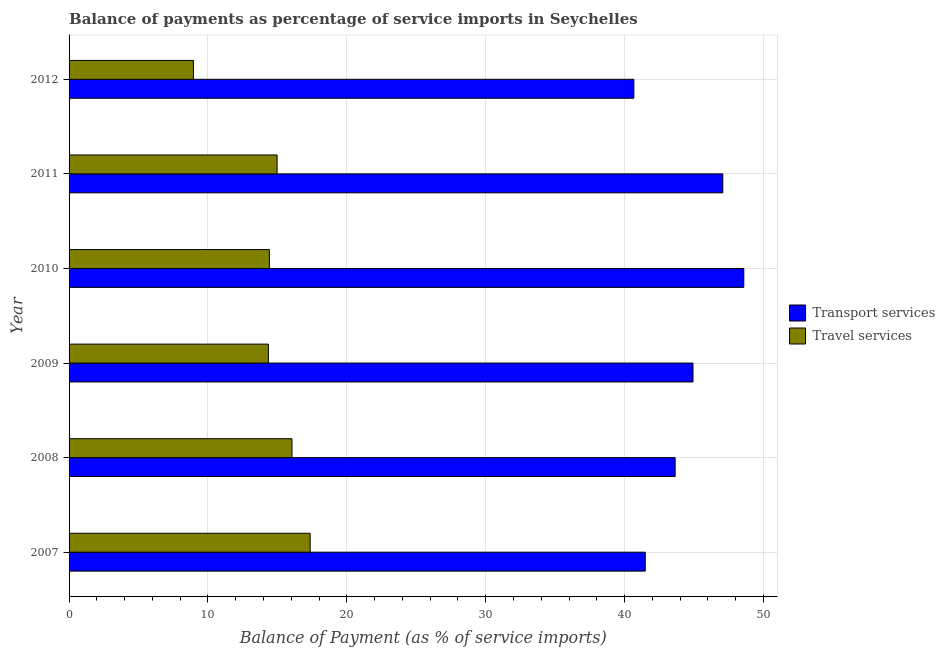How many groups of bars are there?
Your answer should be compact. 6. Are the number of bars on each tick of the Y-axis equal?
Provide a short and direct response. Yes. How many bars are there on the 1st tick from the bottom?
Give a very brief answer. 2. What is the balance of payments of transport services in 2010?
Make the answer very short. 48.59. Across all years, what is the maximum balance of payments of transport services?
Provide a short and direct response. 48.59. Across all years, what is the minimum balance of payments of transport services?
Give a very brief answer. 40.67. In which year was the balance of payments of travel services minimum?
Offer a terse response. 2012. What is the total balance of payments of transport services in the graph?
Your answer should be compact. 266.4. What is the difference between the balance of payments of transport services in 2007 and that in 2010?
Your answer should be compact. -7.1. What is the difference between the balance of payments of transport services in 2008 and the balance of payments of travel services in 2007?
Ensure brevity in your answer.  26.28. What is the average balance of payments of transport services per year?
Give a very brief answer. 44.4. In the year 2008, what is the difference between the balance of payments of transport services and balance of payments of travel services?
Keep it short and to the point. 27.59. Is the balance of payments of travel services in 2007 less than that in 2009?
Your answer should be very brief. No. Is the difference between the balance of payments of travel services in 2010 and 2012 greater than the difference between the balance of payments of transport services in 2010 and 2012?
Your answer should be compact. No. What is the difference between the highest and the second highest balance of payments of transport services?
Ensure brevity in your answer.  1.51. What is the difference between the highest and the lowest balance of payments of travel services?
Provide a succinct answer. 8.41. In how many years, is the balance of payments of transport services greater than the average balance of payments of transport services taken over all years?
Your answer should be compact. 3. Is the sum of the balance of payments of transport services in 2009 and 2010 greater than the maximum balance of payments of travel services across all years?
Give a very brief answer. Yes. What does the 1st bar from the top in 2012 represents?
Your answer should be very brief. Travel services. What does the 2nd bar from the bottom in 2012 represents?
Make the answer very short. Travel services. Are all the bars in the graph horizontal?
Your answer should be very brief. Yes. What is the difference between two consecutive major ticks on the X-axis?
Your answer should be very brief. 10. Does the graph contain any zero values?
Provide a succinct answer. No. Does the graph contain grids?
Provide a succinct answer. Yes. Where does the legend appear in the graph?
Give a very brief answer. Center right. What is the title of the graph?
Your response must be concise. Balance of payments as percentage of service imports in Seychelles. What is the label or title of the X-axis?
Provide a succinct answer. Balance of Payment (as % of service imports). What is the Balance of Payment (as % of service imports) of Transport services in 2007?
Offer a very short reply. 41.49. What is the Balance of Payment (as % of service imports) in Travel services in 2007?
Provide a short and direct response. 17.36. What is the Balance of Payment (as % of service imports) in Transport services in 2008?
Ensure brevity in your answer.  43.64. What is the Balance of Payment (as % of service imports) in Travel services in 2008?
Your response must be concise. 16.05. What is the Balance of Payment (as % of service imports) in Transport services in 2009?
Offer a very short reply. 44.93. What is the Balance of Payment (as % of service imports) in Travel services in 2009?
Provide a short and direct response. 14.35. What is the Balance of Payment (as % of service imports) in Transport services in 2010?
Provide a short and direct response. 48.59. What is the Balance of Payment (as % of service imports) in Travel services in 2010?
Make the answer very short. 14.43. What is the Balance of Payment (as % of service imports) of Transport services in 2011?
Your response must be concise. 47.08. What is the Balance of Payment (as % of service imports) of Travel services in 2011?
Offer a terse response. 14.98. What is the Balance of Payment (as % of service imports) of Transport services in 2012?
Your answer should be compact. 40.67. What is the Balance of Payment (as % of service imports) of Travel services in 2012?
Your answer should be compact. 8.96. Across all years, what is the maximum Balance of Payment (as % of service imports) in Transport services?
Your answer should be very brief. 48.59. Across all years, what is the maximum Balance of Payment (as % of service imports) in Travel services?
Keep it short and to the point. 17.36. Across all years, what is the minimum Balance of Payment (as % of service imports) in Transport services?
Keep it short and to the point. 40.67. Across all years, what is the minimum Balance of Payment (as % of service imports) in Travel services?
Provide a succinct answer. 8.96. What is the total Balance of Payment (as % of service imports) of Transport services in the graph?
Give a very brief answer. 266.4. What is the total Balance of Payment (as % of service imports) in Travel services in the graph?
Ensure brevity in your answer.  86.13. What is the difference between the Balance of Payment (as % of service imports) in Transport services in 2007 and that in 2008?
Provide a succinct answer. -2.15. What is the difference between the Balance of Payment (as % of service imports) in Travel services in 2007 and that in 2008?
Give a very brief answer. 1.31. What is the difference between the Balance of Payment (as % of service imports) in Transport services in 2007 and that in 2009?
Offer a terse response. -3.44. What is the difference between the Balance of Payment (as % of service imports) in Travel services in 2007 and that in 2009?
Offer a very short reply. 3.01. What is the difference between the Balance of Payment (as % of service imports) of Transport services in 2007 and that in 2010?
Ensure brevity in your answer.  -7.1. What is the difference between the Balance of Payment (as % of service imports) in Travel services in 2007 and that in 2010?
Your answer should be compact. 2.94. What is the difference between the Balance of Payment (as % of service imports) of Transport services in 2007 and that in 2011?
Provide a short and direct response. -5.58. What is the difference between the Balance of Payment (as % of service imports) of Travel services in 2007 and that in 2011?
Make the answer very short. 2.38. What is the difference between the Balance of Payment (as % of service imports) of Transport services in 2007 and that in 2012?
Your answer should be compact. 0.82. What is the difference between the Balance of Payment (as % of service imports) in Travel services in 2007 and that in 2012?
Offer a terse response. 8.41. What is the difference between the Balance of Payment (as % of service imports) of Transport services in 2008 and that in 2009?
Provide a short and direct response. -1.28. What is the difference between the Balance of Payment (as % of service imports) of Travel services in 2008 and that in 2009?
Your answer should be compact. 1.7. What is the difference between the Balance of Payment (as % of service imports) of Transport services in 2008 and that in 2010?
Make the answer very short. -4.94. What is the difference between the Balance of Payment (as % of service imports) of Travel services in 2008 and that in 2010?
Ensure brevity in your answer.  1.63. What is the difference between the Balance of Payment (as % of service imports) in Transport services in 2008 and that in 2011?
Make the answer very short. -3.43. What is the difference between the Balance of Payment (as % of service imports) in Travel services in 2008 and that in 2011?
Provide a short and direct response. 1.07. What is the difference between the Balance of Payment (as % of service imports) in Transport services in 2008 and that in 2012?
Keep it short and to the point. 2.97. What is the difference between the Balance of Payment (as % of service imports) in Travel services in 2008 and that in 2012?
Offer a terse response. 7.1. What is the difference between the Balance of Payment (as % of service imports) in Transport services in 2009 and that in 2010?
Ensure brevity in your answer.  -3.66. What is the difference between the Balance of Payment (as % of service imports) of Travel services in 2009 and that in 2010?
Give a very brief answer. -0.07. What is the difference between the Balance of Payment (as % of service imports) of Transport services in 2009 and that in 2011?
Provide a short and direct response. -2.15. What is the difference between the Balance of Payment (as % of service imports) in Travel services in 2009 and that in 2011?
Keep it short and to the point. -0.63. What is the difference between the Balance of Payment (as % of service imports) in Transport services in 2009 and that in 2012?
Give a very brief answer. 4.26. What is the difference between the Balance of Payment (as % of service imports) in Travel services in 2009 and that in 2012?
Give a very brief answer. 5.4. What is the difference between the Balance of Payment (as % of service imports) in Transport services in 2010 and that in 2011?
Your response must be concise. 1.51. What is the difference between the Balance of Payment (as % of service imports) in Travel services in 2010 and that in 2011?
Keep it short and to the point. -0.55. What is the difference between the Balance of Payment (as % of service imports) of Transport services in 2010 and that in 2012?
Give a very brief answer. 7.92. What is the difference between the Balance of Payment (as % of service imports) in Travel services in 2010 and that in 2012?
Provide a short and direct response. 5.47. What is the difference between the Balance of Payment (as % of service imports) in Transport services in 2011 and that in 2012?
Offer a terse response. 6.41. What is the difference between the Balance of Payment (as % of service imports) of Travel services in 2011 and that in 2012?
Keep it short and to the point. 6.03. What is the difference between the Balance of Payment (as % of service imports) of Transport services in 2007 and the Balance of Payment (as % of service imports) of Travel services in 2008?
Provide a succinct answer. 25.44. What is the difference between the Balance of Payment (as % of service imports) of Transport services in 2007 and the Balance of Payment (as % of service imports) of Travel services in 2009?
Keep it short and to the point. 27.14. What is the difference between the Balance of Payment (as % of service imports) of Transport services in 2007 and the Balance of Payment (as % of service imports) of Travel services in 2010?
Your response must be concise. 27.07. What is the difference between the Balance of Payment (as % of service imports) in Transport services in 2007 and the Balance of Payment (as % of service imports) in Travel services in 2011?
Your answer should be compact. 26.51. What is the difference between the Balance of Payment (as % of service imports) of Transport services in 2007 and the Balance of Payment (as % of service imports) of Travel services in 2012?
Offer a terse response. 32.54. What is the difference between the Balance of Payment (as % of service imports) of Transport services in 2008 and the Balance of Payment (as % of service imports) of Travel services in 2009?
Provide a short and direct response. 29.29. What is the difference between the Balance of Payment (as % of service imports) of Transport services in 2008 and the Balance of Payment (as % of service imports) of Travel services in 2010?
Give a very brief answer. 29.22. What is the difference between the Balance of Payment (as % of service imports) in Transport services in 2008 and the Balance of Payment (as % of service imports) in Travel services in 2011?
Provide a succinct answer. 28.66. What is the difference between the Balance of Payment (as % of service imports) of Transport services in 2008 and the Balance of Payment (as % of service imports) of Travel services in 2012?
Make the answer very short. 34.69. What is the difference between the Balance of Payment (as % of service imports) of Transport services in 2009 and the Balance of Payment (as % of service imports) of Travel services in 2010?
Make the answer very short. 30.5. What is the difference between the Balance of Payment (as % of service imports) in Transport services in 2009 and the Balance of Payment (as % of service imports) in Travel services in 2011?
Your response must be concise. 29.95. What is the difference between the Balance of Payment (as % of service imports) in Transport services in 2009 and the Balance of Payment (as % of service imports) in Travel services in 2012?
Your answer should be compact. 35.97. What is the difference between the Balance of Payment (as % of service imports) in Transport services in 2010 and the Balance of Payment (as % of service imports) in Travel services in 2011?
Offer a terse response. 33.61. What is the difference between the Balance of Payment (as % of service imports) in Transport services in 2010 and the Balance of Payment (as % of service imports) in Travel services in 2012?
Keep it short and to the point. 39.63. What is the difference between the Balance of Payment (as % of service imports) in Transport services in 2011 and the Balance of Payment (as % of service imports) in Travel services in 2012?
Provide a short and direct response. 38.12. What is the average Balance of Payment (as % of service imports) in Transport services per year?
Give a very brief answer. 44.4. What is the average Balance of Payment (as % of service imports) of Travel services per year?
Offer a very short reply. 14.35. In the year 2007, what is the difference between the Balance of Payment (as % of service imports) of Transport services and Balance of Payment (as % of service imports) of Travel services?
Give a very brief answer. 24.13. In the year 2008, what is the difference between the Balance of Payment (as % of service imports) in Transport services and Balance of Payment (as % of service imports) in Travel services?
Provide a short and direct response. 27.59. In the year 2009, what is the difference between the Balance of Payment (as % of service imports) in Transport services and Balance of Payment (as % of service imports) in Travel services?
Keep it short and to the point. 30.57. In the year 2010, what is the difference between the Balance of Payment (as % of service imports) of Transport services and Balance of Payment (as % of service imports) of Travel services?
Your answer should be compact. 34.16. In the year 2011, what is the difference between the Balance of Payment (as % of service imports) in Transport services and Balance of Payment (as % of service imports) in Travel services?
Offer a very short reply. 32.1. In the year 2012, what is the difference between the Balance of Payment (as % of service imports) of Transport services and Balance of Payment (as % of service imports) of Travel services?
Give a very brief answer. 31.72. What is the ratio of the Balance of Payment (as % of service imports) of Transport services in 2007 to that in 2008?
Your response must be concise. 0.95. What is the ratio of the Balance of Payment (as % of service imports) in Travel services in 2007 to that in 2008?
Offer a terse response. 1.08. What is the ratio of the Balance of Payment (as % of service imports) in Transport services in 2007 to that in 2009?
Your answer should be very brief. 0.92. What is the ratio of the Balance of Payment (as % of service imports) in Travel services in 2007 to that in 2009?
Offer a terse response. 1.21. What is the ratio of the Balance of Payment (as % of service imports) in Transport services in 2007 to that in 2010?
Your answer should be compact. 0.85. What is the ratio of the Balance of Payment (as % of service imports) in Travel services in 2007 to that in 2010?
Your response must be concise. 1.2. What is the ratio of the Balance of Payment (as % of service imports) in Transport services in 2007 to that in 2011?
Your response must be concise. 0.88. What is the ratio of the Balance of Payment (as % of service imports) in Travel services in 2007 to that in 2011?
Your response must be concise. 1.16. What is the ratio of the Balance of Payment (as % of service imports) of Transport services in 2007 to that in 2012?
Your answer should be very brief. 1.02. What is the ratio of the Balance of Payment (as % of service imports) in Travel services in 2007 to that in 2012?
Provide a succinct answer. 1.94. What is the ratio of the Balance of Payment (as % of service imports) in Transport services in 2008 to that in 2009?
Give a very brief answer. 0.97. What is the ratio of the Balance of Payment (as % of service imports) in Travel services in 2008 to that in 2009?
Provide a succinct answer. 1.12. What is the ratio of the Balance of Payment (as % of service imports) in Transport services in 2008 to that in 2010?
Give a very brief answer. 0.9. What is the ratio of the Balance of Payment (as % of service imports) in Travel services in 2008 to that in 2010?
Keep it short and to the point. 1.11. What is the ratio of the Balance of Payment (as % of service imports) of Transport services in 2008 to that in 2011?
Make the answer very short. 0.93. What is the ratio of the Balance of Payment (as % of service imports) in Travel services in 2008 to that in 2011?
Your answer should be compact. 1.07. What is the ratio of the Balance of Payment (as % of service imports) in Transport services in 2008 to that in 2012?
Provide a succinct answer. 1.07. What is the ratio of the Balance of Payment (as % of service imports) in Travel services in 2008 to that in 2012?
Offer a terse response. 1.79. What is the ratio of the Balance of Payment (as % of service imports) of Transport services in 2009 to that in 2010?
Give a very brief answer. 0.92. What is the ratio of the Balance of Payment (as % of service imports) of Transport services in 2009 to that in 2011?
Give a very brief answer. 0.95. What is the ratio of the Balance of Payment (as % of service imports) in Travel services in 2009 to that in 2011?
Provide a short and direct response. 0.96. What is the ratio of the Balance of Payment (as % of service imports) in Transport services in 2009 to that in 2012?
Provide a succinct answer. 1.1. What is the ratio of the Balance of Payment (as % of service imports) of Travel services in 2009 to that in 2012?
Your answer should be compact. 1.6. What is the ratio of the Balance of Payment (as % of service imports) in Transport services in 2010 to that in 2011?
Ensure brevity in your answer.  1.03. What is the ratio of the Balance of Payment (as % of service imports) in Transport services in 2010 to that in 2012?
Make the answer very short. 1.19. What is the ratio of the Balance of Payment (as % of service imports) of Travel services in 2010 to that in 2012?
Keep it short and to the point. 1.61. What is the ratio of the Balance of Payment (as % of service imports) in Transport services in 2011 to that in 2012?
Ensure brevity in your answer.  1.16. What is the ratio of the Balance of Payment (as % of service imports) of Travel services in 2011 to that in 2012?
Offer a terse response. 1.67. What is the difference between the highest and the second highest Balance of Payment (as % of service imports) in Transport services?
Offer a terse response. 1.51. What is the difference between the highest and the second highest Balance of Payment (as % of service imports) in Travel services?
Provide a short and direct response. 1.31. What is the difference between the highest and the lowest Balance of Payment (as % of service imports) in Transport services?
Provide a short and direct response. 7.92. What is the difference between the highest and the lowest Balance of Payment (as % of service imports) in Travel services?
Make the answer very short. 8.41. 